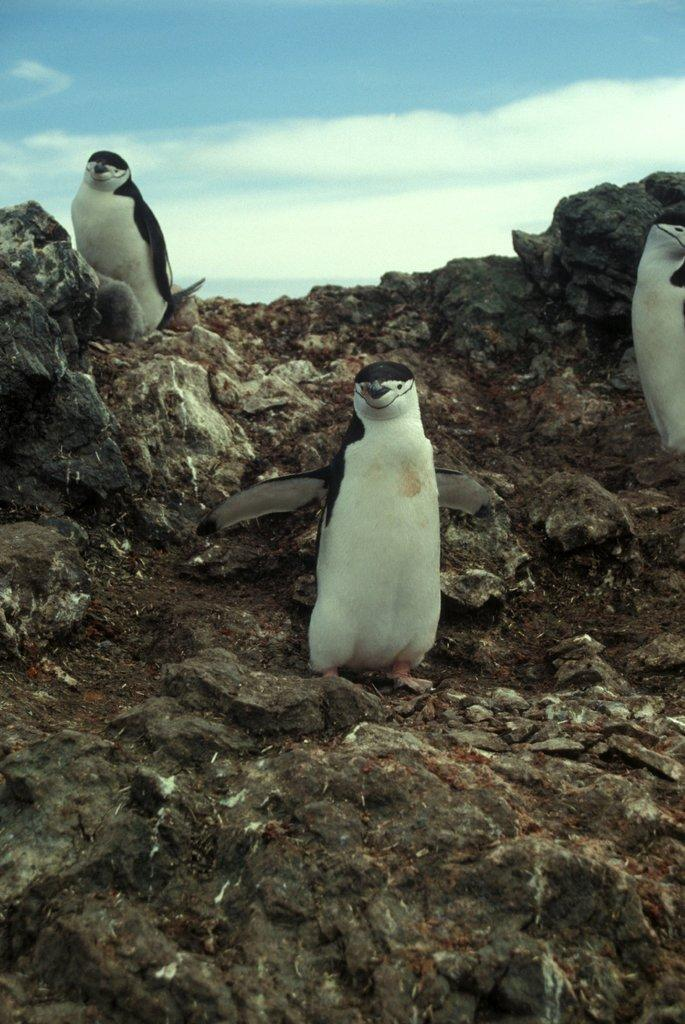What type of animals are in the image? There are penguins in the image. Where are the penguins located? The penguins are on a rock. What can be seen in the sky in the image? There are clouds visible in the sky. What type of fish is the writer using to stir the soup with a spoon in the image? There is no fish, writer, or spoon present in the image; it features penguins on a rock with clouds in the sky. 